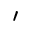<formula> <loc_0><loc_0><loc_500><loc_500>^ { \prime }</formula> 